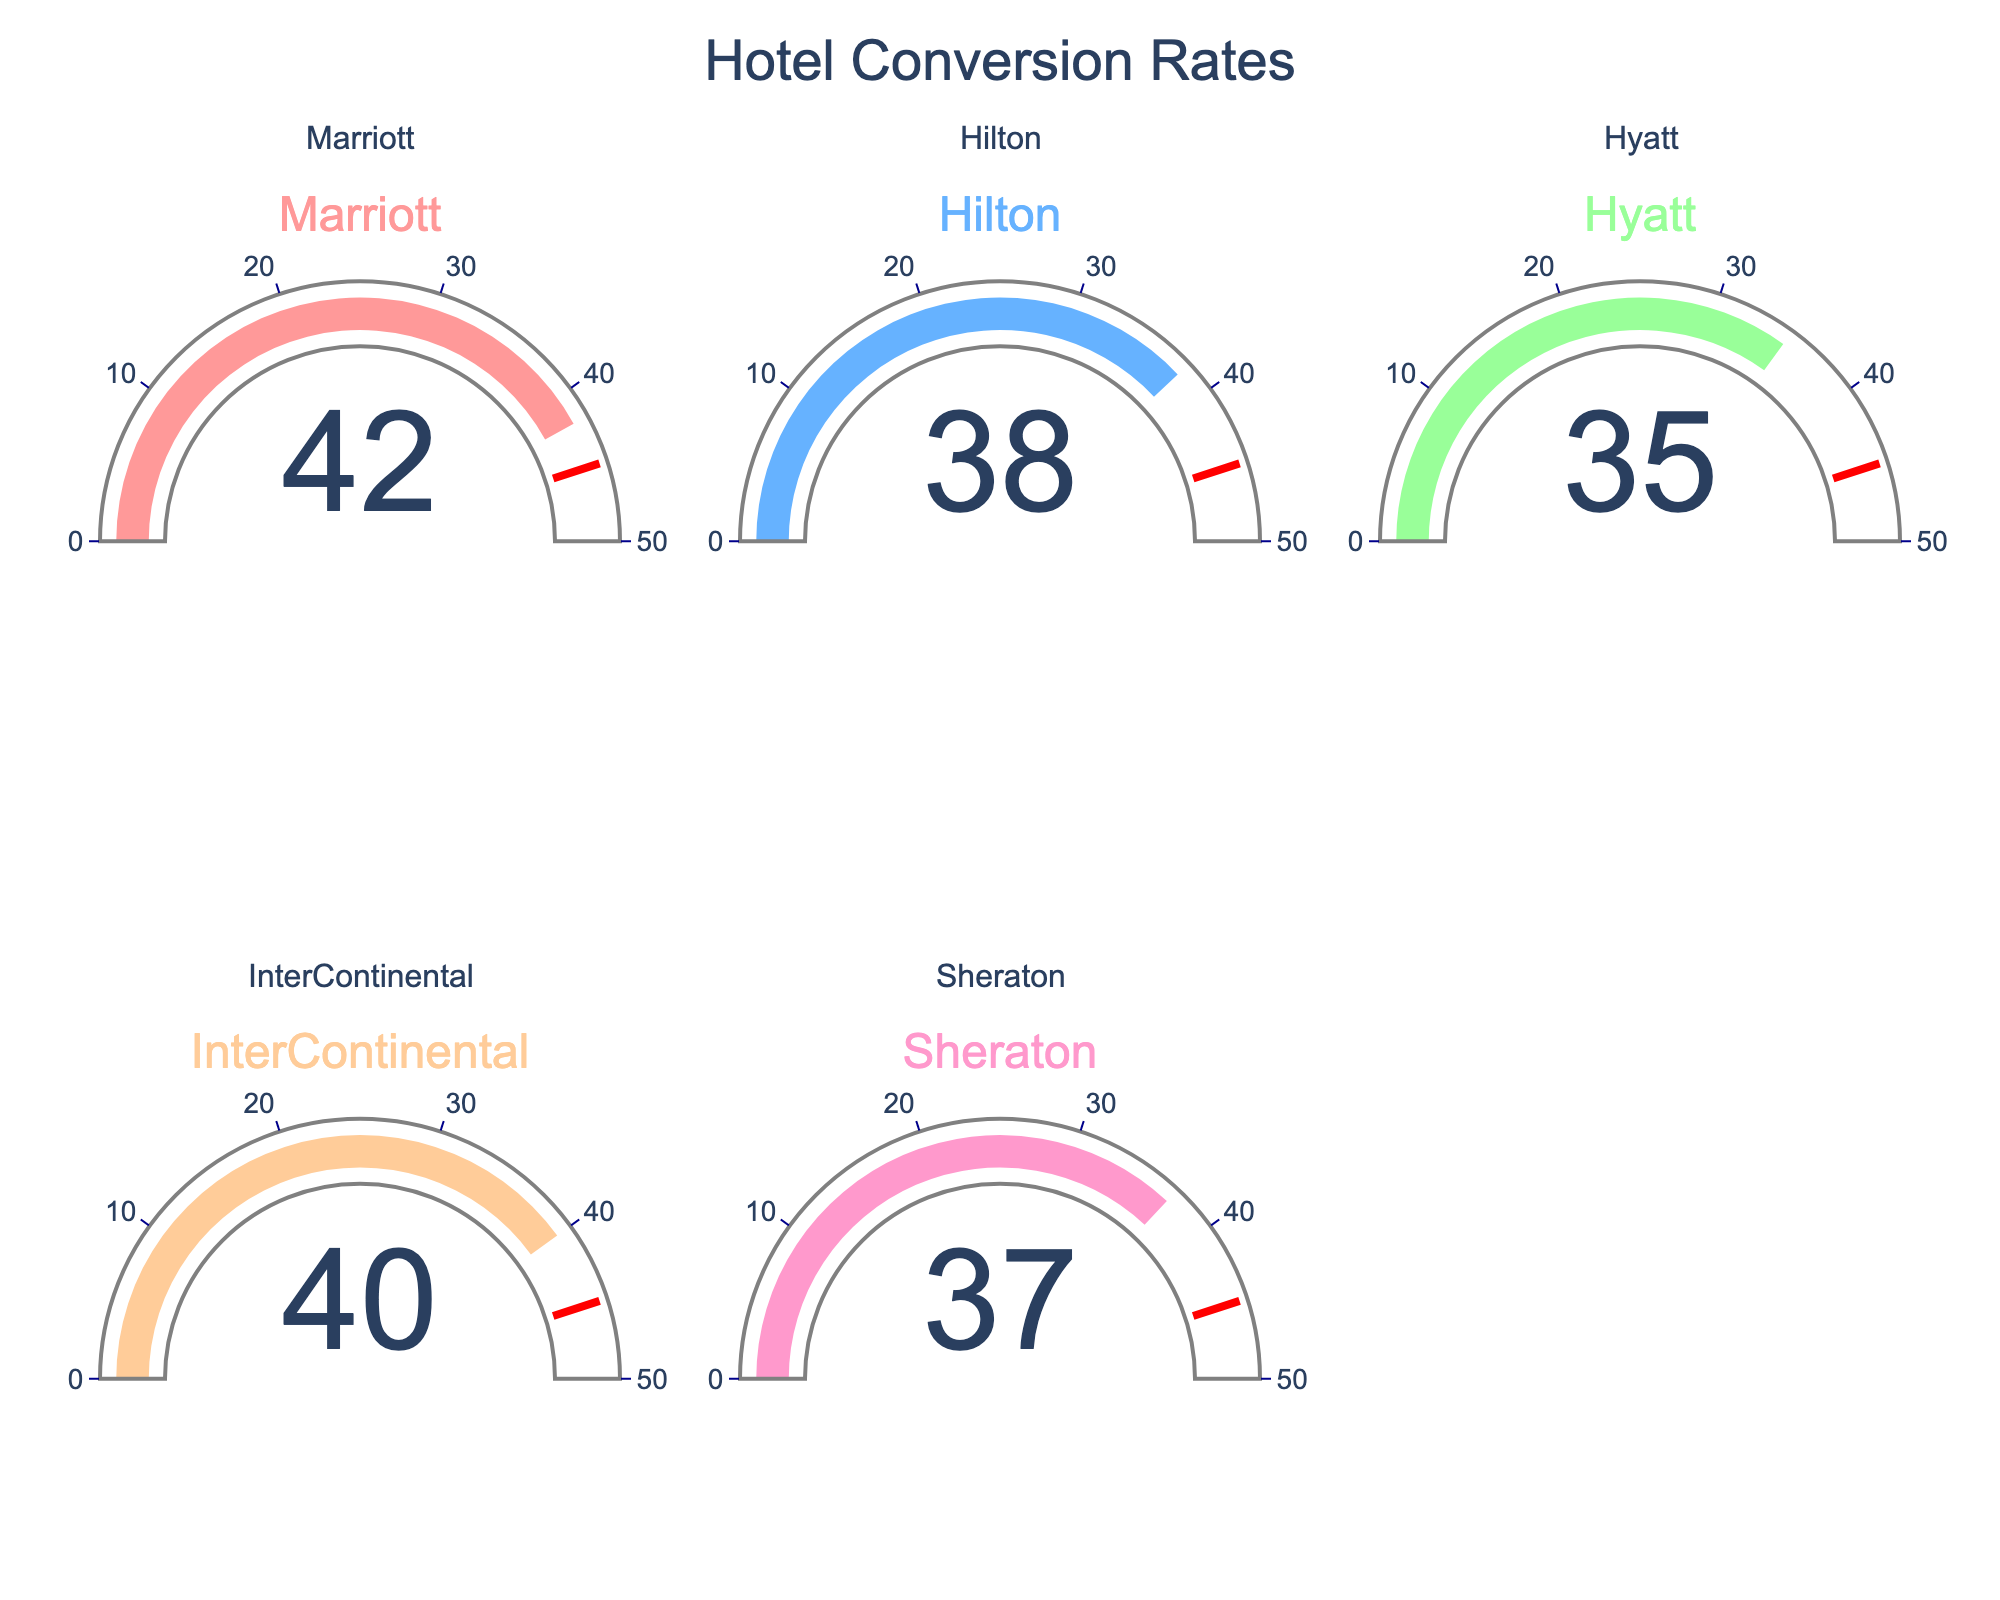Which hotel has the highest conversion rate? Marriott has the highest conversion rate as indicated by the figure with a value of 42.
Answer: Marriott What is the lowest conversion rate among the hotels? The lowest conversion rate is for Hyatt, with a value of 35 as shown in the figure.
Answer: Hyatt What's the average conversion rate of all hotels? Sum up all conversion rates (42 + 38 + 35 + 40 + 37) = 192, then divide by the number of hotels (192/5).
Answer: 38.4 How many hotels have a conversion rate above 35? The figure shows that Marriott (42), Hilton (38), InterContinental (40), and Sheraton (37) have conversion rates above 35.
Answer: 4 Which hotel has a conversion rate closest to the threshold value of 45? Marriott has a conversion rate of 42, which is the closest to the threshold value of 45 as shown in the figure.
Answer: Marriott Is there any hotel with a conversion rate below 40? The figure indicates that Hilton (38), Hyatt (35), and Sheraton (37) have conversion rates below 40.
Answer: Yes How much higher is Marriott's conversion rate than Hyatt's? Marriott's conversion rate is 42 and Hyatt's is 35. Subtract 35 from 42 to find the difference (42 - 35).
Answer: 7 Do any two hotels have the same or equal conversion rate? No two hotels in the figure have the same conversion rate. Each hotel has a unique conversion rate.
Answer: No Which hotel falls in the 30-40 range of conversion rate colored in light shades? Hilton (38), Hyatt (35), and Sheraton (37) fall in the 30-40 range of conversion rate, represented by light shades in the figure.
Answer: Hilton, Hyatt, Sheraton Do most hotels have conversion rates above or below the threshold value indicated in the gauges? Most hotels have conversion rates below the threshold value of 45 as indicated in the figure. All hotels' conversion rates are below the threshold.
Answer: Below 